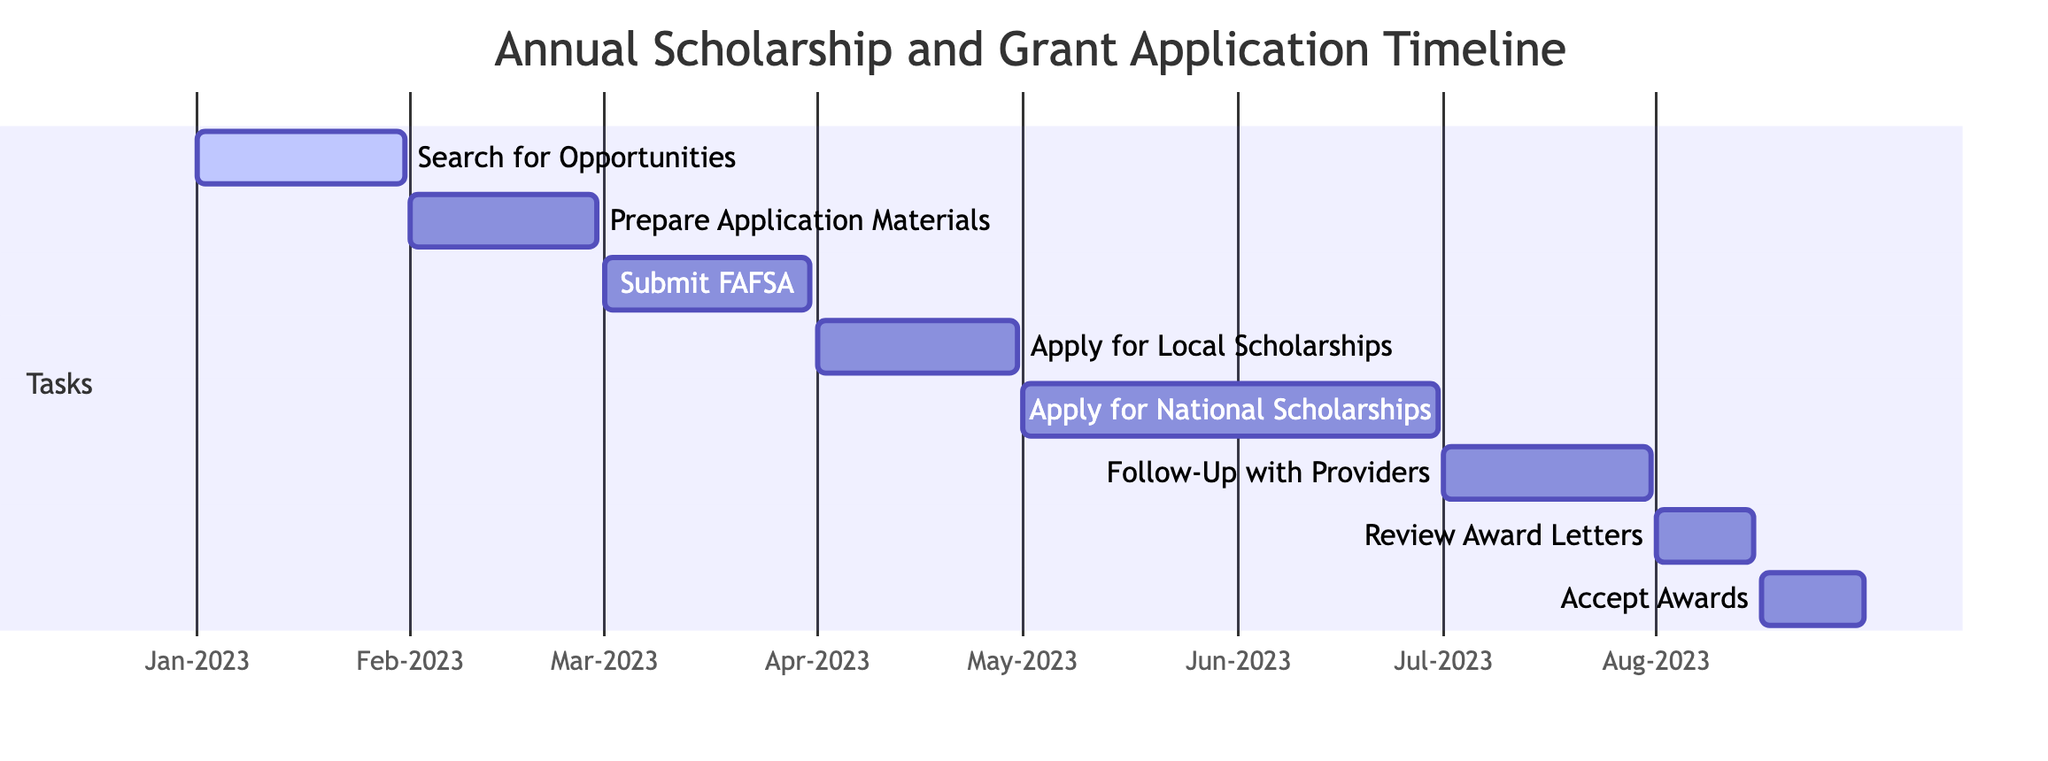What is the duration of the "Search for Opportunities" task? The "Search for Opportunities" task starts on January 1, 2023, and ends on January 31, 2023. Therefore, the duration is one month.
Answer: one month How many tasks are listed in the Gantt Chart? The Gantt Chart contains a total of eight tasks listed under the "Tasks" section, which are all related to the scholarship and grant application process.
Answer: eight What is the end date of the "Apply for Local Scholarships" task? The "Apply for Local Scholarships" task ends on April 30, 2023, as indicated in the Gantt Chart.
Answer: April 30, 2023 Which task has the earliest start date? The task "Search for Opportunities" has the earliest start date, which is January 1, 2023.
Answer: Search for Opportunities How long is the period between "Submit FAFSA" and "Apply for Local Scholarships"? "Submit FAFSA" ends on March 31, 2023, and "Apply for Local Scholarships" starts on April 1, 2023. The period between these two tasks is one day.
Answer: one day Which task follows "Prepare Application Materials" in the timeline? The task that follows "Prepare Application Materials" is "Submit FAFSA," which starts immediately after on March 1, 2023.
Answer: Submit FAFSA What is the total duration of the "Apply for National Scholarships" task? The "Apply for National Scholarships" task starts on May 1, 2023, and ends on June 30, 2023, giving it a duration of two months.
Answer: two months During which month does the task "Review Award Letters" take place? The "Review Award Letters" task takes place in August 2023, as it starts on August 1, 2023, and ends on August 15, 2023.
Answer: August Which task is scheduled to occur immediately after "Accept Awards"? There are no tasks scheduled to occur immediately after "Accept Awards"; it is the last task in the timeline.
Answer: none 